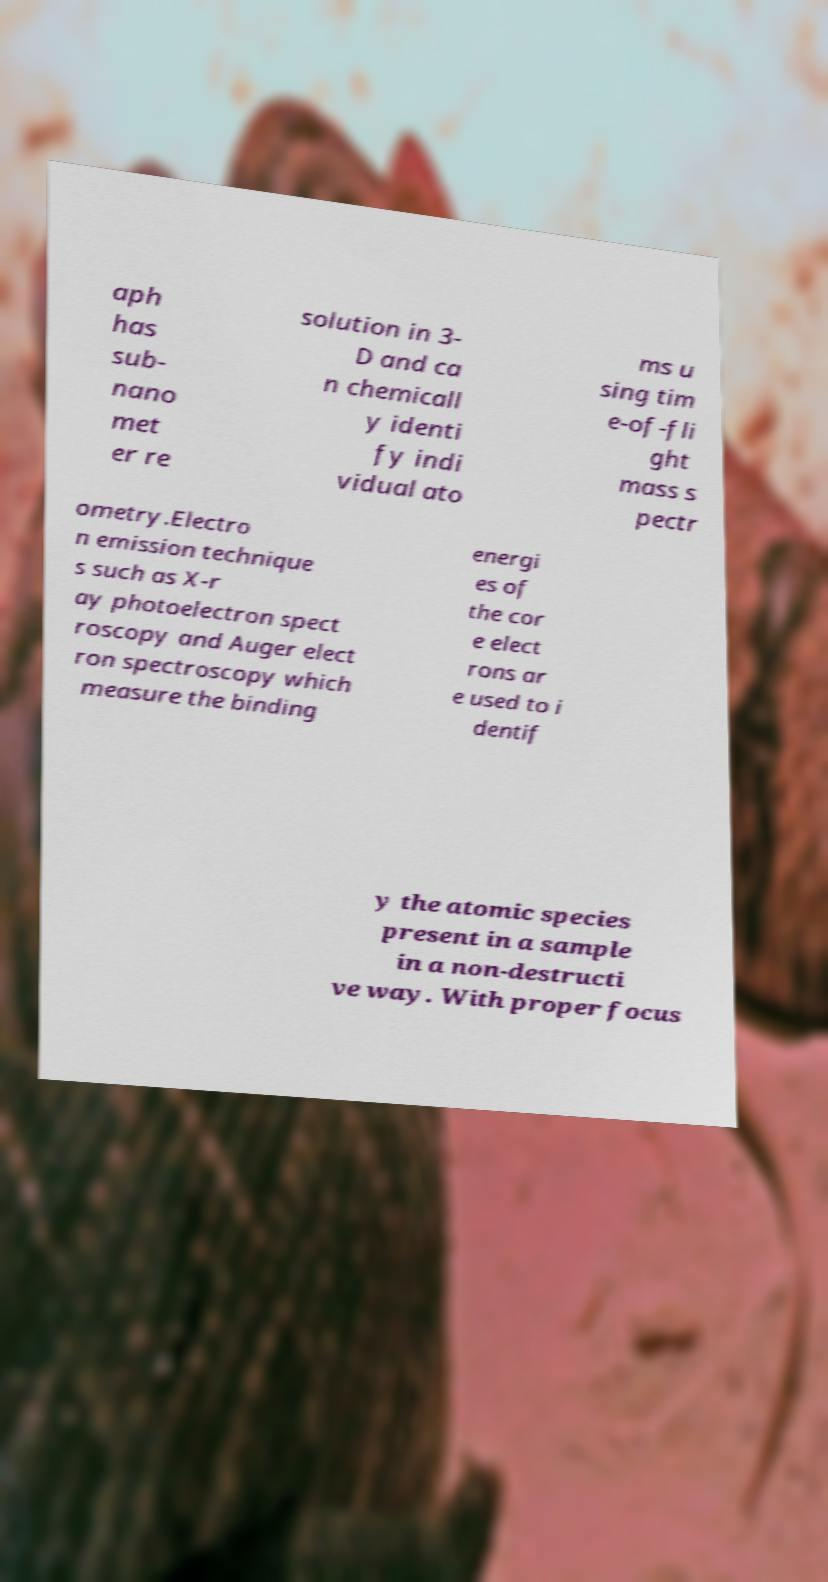Could you extract and type out the text from this image? aph has sub- nano met er re solution in 3- D and ca n chemicall y identi fy indi vidual ato ms u sing tim e-of-fli ght mass s pectr ometry.Electro n emission technique s such as X-r ay photoelectron spect roscopy and Auger elect ron spectroscopy which measure the binding energi es of the cor e elect rons ar e used to i dentif y the atomic species present in a sample in a non-destructi ve way. With proper focus 